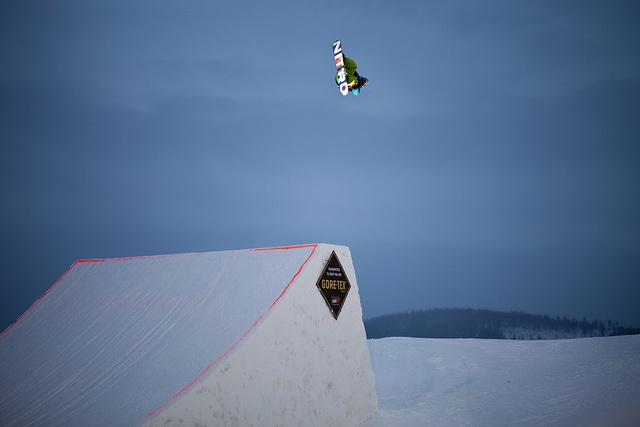Describe the objects in this image and their specific colors. I can see people in darkblue, black, darkgreen, and gray tones and snowboard in darkblue, white, gray, navy, and darkgray tones in this image. 